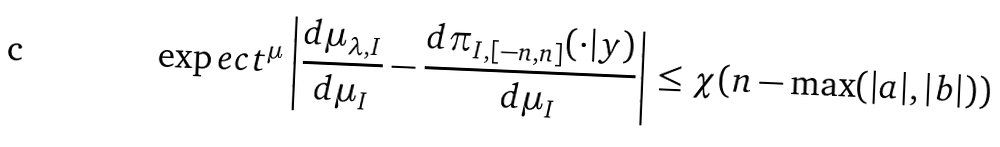<formula> <loc_0><loc_0><loc_500><loc_500>\exp e c t ^ { \mu } \left | \frac { d \mu _ { \lambda , I } } { d \mu _ { I } } - \frac { d \pi _ { I , [ - n , n ] } ( \cdot | y ) } { d \mu _ { I } } \right | \leq \chi ( n - \max ( | a | , | b | ) )</formula> 